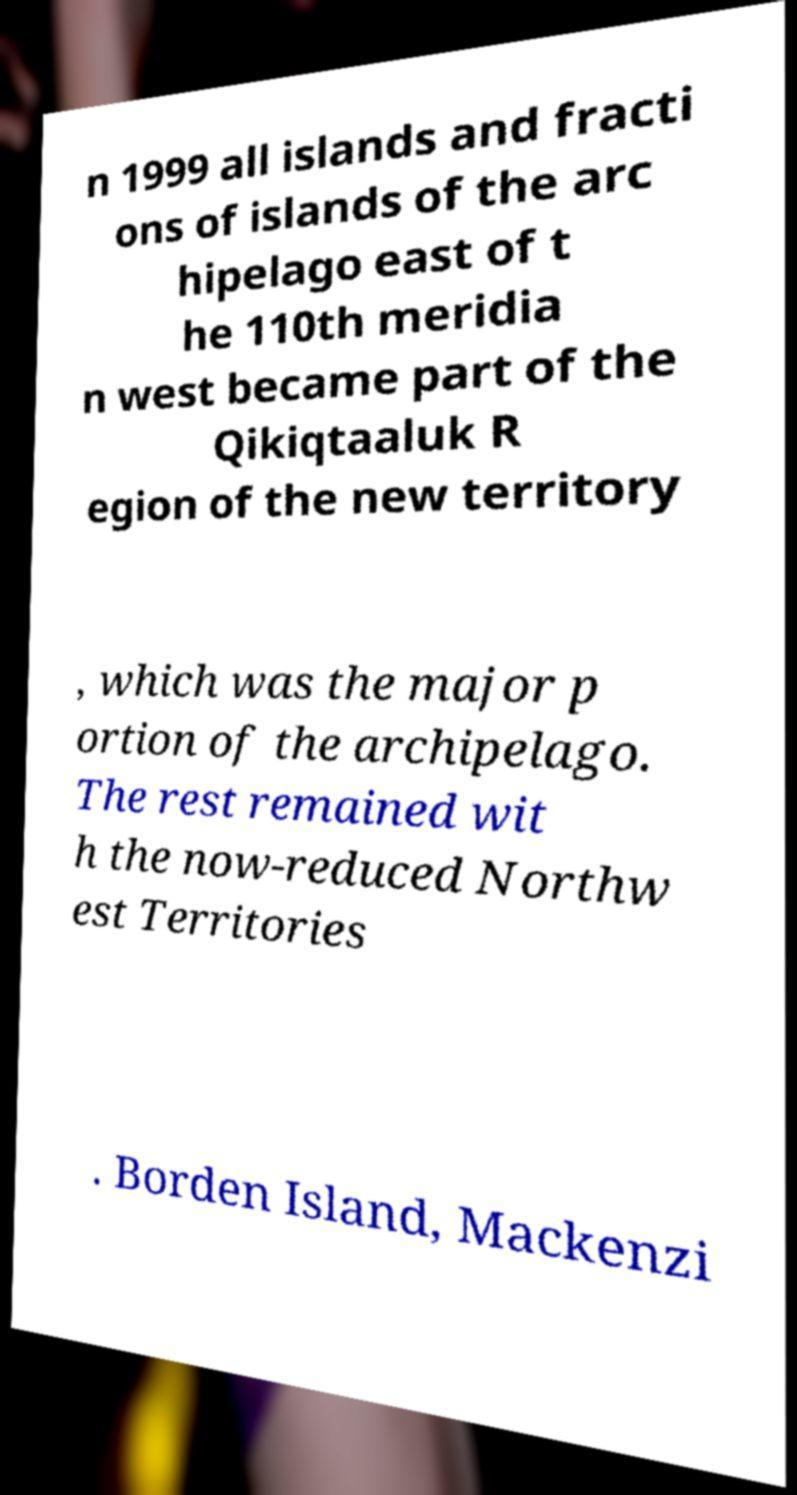Please identify and transcribe the text found in this image. n 1999 all islands and fracti ons of islands of the arc hipelago east of t he 110th meridia n west became part of the Qikiqtaaluk R egion of the new territory , which was the major p ortion of the archipelago. The rest remained wit h the now-reduced Northw est Territories . Borden Island, Mackenzi 